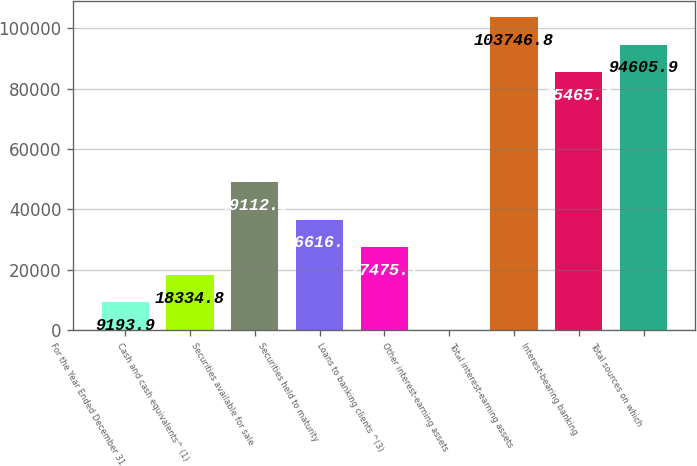Convert chart to OTSL. <chart><loc_0><loc_0><loc_500><loc_500><bar_chart><fcel>For the Year Ended December 31<fcel>Cash and cash equivalents^ (1)<fcel>Securities available for sale<fcel>Securities held to maturity<fcel>Loans to banking clients ^(3)<fcel>Other interest-earning assets<fcel>Total interest-earning assets<fcel>Interest-bearing banking<fcel>Total sources on which<nl><fcel>9193.9<fcel>18334.8<fcel>49112<fcel>36616.6<fcel>27475.7<fcel>53<fcel>103747<fcel>85465<fcel>94605.9<nl></chart> 